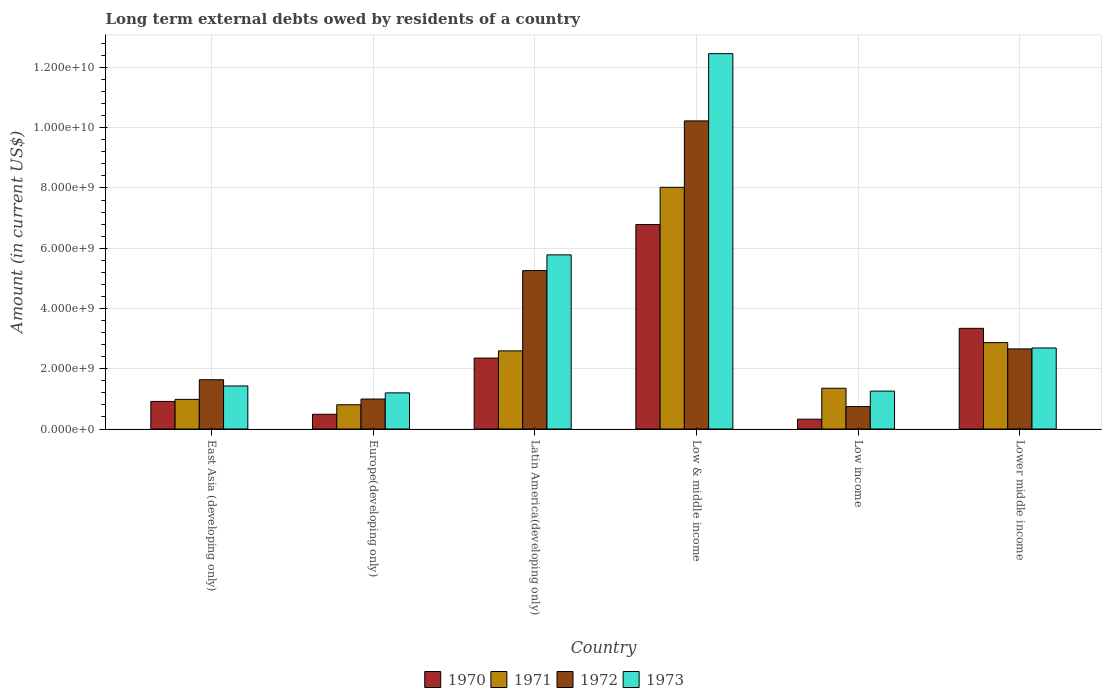Are the number of bars on each tick of the X-axis equal?
Keep it short and to the point. Yes. How many bars are there on the 6th tick from the left?
Make the answer very short. 4. What is the label of the 3rd group of bars from the left?
Offer a terse response. Latin America(developing only). In how many cases, is the number of bars for a given country not equal to the number of legend labels?
Your response must be concise. 0. What is the amount of long-term external debts owed by residents in 1973 in Latin America(developing only)?
Offer a very short reply. 5.78e+09. Across all countries, what is the maximum amount of long-term external debts owed by residents in 1970?
Make the answer very short. 6.79e+09. Across all countries, what is the minimum amount of long-term external debts owed by residents in 1973?
Your response must be concise. 1.20e+09. In which country was the amount of long-term external debts owed by residents in 1972 maximum?
Keep it short and to the point. Low & middle income. What is the total amount of long-term external debts owed by residents in 1972 in the graph?
Your answer should be compact. 2.15e+1. What is the difference between the amount of long-term external debts owed by residents in 1971 in Europe(developing only) and that in Lower middle income?
Offer a terse response. -2.06e+09. What is the difference between the amount of long-term external debts owed by residents in 1971 in Low income and the amount of long-term external debts owed by residents in 1970 in Lower middle income?
Ensure brevity in your answer.  -1.99e+09. What is the average amount of long-term external debts owed by residents in 1973 per country?
Give a very brief answer. 4.14e+09. What is the difference between the amount of long-term external debts owed by residents of/in 1971 and amount of long-term external debts owed by residents of/in 1972 in Low income?
Offer a very short reply. 6.10e+08. In how many countries, is the amount of long-term external debts owed by residents in 1973 greater than 400000000 US$?
Provide a succinct answer. 6. What is the ratio of the amount of long-term external debts owed by residents in 1971 in Europe(developing only) to that in Low & middle income?
Keep it short and to the point. 0.1. Is the amount of long-term external debts owed by residents in 1970 in Latin America(developing only) less than that in Lower middle income?
Your answer should be very brief. Yes. What is the difference between the highest and the second highest amount of long-term external debts owed by residents in 1972?
Make the answer very short. 7.57e+09. What is the difference between the highest and the lowest amount of long-term external debts owed by residents in 1971?
Provide a short and direct response. 7.22e+09. In how many countries, is the amount of long-term external debts owed by residents in 1971 greater than the average amount of long-term external debts owed by residents in 1971 taken over all countries?
Ensure brevity in your answer.  2. Is it the case that in every country, the sum of the amount of long-term external debts owed by residents in 1973 and amount of long-term external debts owed by residents in 1970 is greater than the sum of amount of long-term external debts owed by residents in 1971 and amount of long-term external debts owed by residents in 1972?
Keep it short and to the point. No. What does the 1st bar from the right in East Asia (developing only) represents?
Your response must be concise. 1973. Is it the case that in every country, the sum of the amount of long-term external debts owed by residents in 1971 and amount of long-term external debts owed by residents in 1970 is greater than the amount of long-term external debts owed by residents in 1973?
Offer a terse response. No. How many bars are there?
Keep it short and to the point. 24. What is the difference between two consecutive major ticks on the Y-axis?
Offer a terse response. 2.00e+09. Does the graph contain any zero values?
Keep it short and to the point. No. Where does the legend appear in the graph?
Your response must be concise. Bottom center. What is the title of the graph?
Give a very brief answer. Long term external debts owed by residents of a country. Does "2011" appear as one of the legend labels in the graph?
Provide a succinct answer. No. What is the label or title of the X-axis?
Keep it short and to the point. Country. What is the Amount (in current US$) in 1970 in East Asia (developing only)?
Your answer should be compact. 9.15e+08. What is the Amount (in current US$) in 1971 in East Asia (developing only)?
Your answer should be very brief. 9.84e+08. What is the Amount (in current US$) of 1972 in East Asia (developing only)?
Your response must be concise. 1.64e+09. What is the Amount (in current US$) of 1973 in East Asia (developing only)?
Provide a succinct answer. 1.43e+09. What is the Amount (in current US$) of 1970 in Europe(developing only)?
Your response must be concise. 4.89e+08. What is the Amount (in current US$) of 1971 in Europe(developing only)?
Provide a short and direct response. 8.05e+08. What is the Amount (in current US$) of 1972 in Europe(developing only)?
Provide a succinct answer. 9.95e+08. What is the Amount (in current US$) in 1973 in Europe(developing only)?
Offer a terse response. 1.20e+09. What is the Amount (in current US$) of 1970 in Latin America(developing only)?
Your response must be concise. 2.35e+09. What is the Amount (in current US$) of 1971 in Latin America(developing only)?
Make the answer very short. 2.59e+09. What is the Amount (in current US$) of 1972 in Latin America(developing only)?
Offer a very short reply. 5.26e+09. What is the Amount (in current US$) of 1973 in Latin America(developing only)?
Ensure brevity in your answer.  5.78e+09. What is the Amount (in current US$) in 1970 in Low & middle income?
Make the answer very short. 6.79e+09. What is the Amount (in current US$) of 1971 in Low & middle income?
Your answer should be compact. 8.02e+09. What is the Amount (in current US$) of 1972 in Low & middle income?
Your answer should be compact. 1.02e+1. What is the Amount (in current US$) in 1973 in Low & middle income?
Give a very brief answer. 1.25e+1. What is the Amount (in current US$) of 1970 in Low income?
Keep it short and to the point. 3.26e+08. What is the Amount (in current US$) in 1971 in Low income?
Provide a short and direct response. 1.35e+09. What is the Amount (in current US$) of 1972 in Low income?
Ensure brevity in your answer.  7.44e+08. What is the Amount (in current US$) in 1973 in Low income?
Offer a terse response. 1.26e+09. What is the Amount (in current US$) of 1970 in Lower middle income?
Offer a very short reply. 3.34e+09. What is the Amount (in current US$) in 1971 in Lower middle income?
Offer a very short reply. 2.87e+09. What is the Amount (in current US$) of 1972 in Lower middle income?
Your answer should be compact. 2.66e+09. What is the Amount (in current US$) of 1973 in Lower middle income?
Provide a short and direct response. 2.69e+09. Across all countries, what is the maximum Amount (in current US$) in 1970?
Make the answer very short. 6.79e+09. Across all countries, what is the maximum Amount (in current US$) of 1971?
Make the answer very short. 8.02e+09. Across all countries, what is the maximum Amount (in current US$) in 1972?
Provide a short and direct response. 1.02e+1. Across all countries, what is the maximum Amount (in current US$) in 1973?
Give a very brief answer. 1.25e+1. Across all countries, what is the minimum Amount (in current US$) in 1970?
Ensure brevity in your answer.  3.26e+08. Across all countries, what is the minimum Amount (in current US$) of 1971?
Your answer should be compact. 8.05e+08. Across all countries, what is the minimum Amount (in current US$) in 1972?
Give a very brief answer. 7.44e+08. Across all countries, what is the minimum Amount (in current US$) of 1973?
Offer a very short reply. 1.20e+09. What is the total Amount (in current US$) in 1970 in the graph?
Your response must be concise. 1.42e+1. What is the total Amount (in current US$) in 1971 in the graph?
Offer a terse response. 1.66e+1. What is the total Amount (in current US$) of 1972 in the graph?
Your answer should be compact. 2.15e+1. What is the total Amount (in current US$) of 1973 in the graph?
Ensure brevity in your answer.  2.48e+1. What is the difference between the Amount (in current US$) in 1970 in East Asia (developing only) and that in Europe(developing only)?
Your answer should be compact. 4.26e+08. What is the difference between the Amount (in current US$) in 1971 in East Asia (developing only) and that in Europe(developing only)?
Keep it short and to the point. 1.79e+08. What is the difference between the Amount (in current US$) in 1972 in East Asia (developing only) and that in Europe(developing only)?
Provide a succinct answer. 6.40e+08. What is the difference between the Amount (in current US$) of 1973 in East Asia (developing only) and that in Europe(developing only)?
Provide a short and direct response. 2.29e+08. What is the difference between the Amount (in current US$) in 1970 in East Asia (developing only) and that in Latin America(developing only)?
Keep it short and to the point. -1.44e+09. What is the difference between the Amount (in current US$) in 1971 in East Asia (developing only) and that in Latin America(developing only)?
Your response must be concise. -1.61e+09. What is the difference between the Amount (in current US$) in 1972 in East Asia (developing only) and that in Latin America(developing only)?
Give a very brief answer. -3.62e+09. What is the difference between the Amount (in current US$) of 1973 in East Asia (developing only) and that in Latin America(developing only)?
Keep it short and to the point. -4.35e+09. What is the difference between the Amount (in current US$) in 1970 in East Asia (developing only) and that in Low & middle income?
Offer a very short reply. -5.87e+09. What is the difference between the Amount (in current US$) in 1971 in East Asia (developing only) and that in Low & middle income?
Offer a terse response. -7.04e+09. What is the difference between the Amount (in current US$) of 1972 in East Asia (developing only) and that in Low & middle income?
Provide a short and direct response. -8.59e+09. What is the difference between the Amount (in current US$) of 1973 in East Asia (developing only) and that in Low & middle income?
Provide a short and direct response. -1.10e+1. What is the difference between the Amount (in current US$) of 1970 in East Asia (developing only) and that in Low income?
Your answer should be compact. 5.89e+08. What is the difference between the Amount (in current US$) in 1971 in East Asia (developing only) and that in Low income?
Offer a very short reply. -3.69e+08. What is the difference between the Amount (in current US$) of 1972 in East Asia (developing only) and that in Low income?
Keep it short and to the point. 8.92e+08. What is the difference between the Amount (in current US$) of 1973 in East Asia (developing only) and that in Low income?
Your response must be concise. 1.72e+08. What is the difference between the Amount (in current US$) of 1970 in East Asia (developing only) and that in Lower middle income?
Your answer should be very brief. -2.43e+09. What is the difference between the Amount (in current US$) in 1971 in East Asia (developing only) and that in Lower middle income?
Your response must be concise. -1.88e+09. What is the difference between the Amount (in current US$) of 1972 in East Asia (developing only) and that in Lower middle income?
Provide a succinct answer. -1.02e+09. What is the difference between the Amount (in current US$) in 1973 in East Asia (developing only) and that in Lower middle income?
Make the answer very short. -1.26e+09. What is the difference between the Amount (in current US$) in 1970 in Europe(developing only) and that in Latin America(developing only)?
Your answer should be compact. -1.86e+09. What is the difference between the Amount (in current US$) in 1971 in Europe(developing only) and that in Latin America(developing only)?
Keep it short and to the point. -1.79e+09. What is the difference between the Amount (in current US$) of 1972 in Europe(developing only) and that in Latin America(developing only)?
Make the answer very short. -4.26e+09. What is the difference between the Amount (in current US$) of 1973 in Europe(developing only) and that in Latin America(developing only)?
Your answer should be very brief. -4.58e+09. What is the difference between the Amount (in current US$) of 1970 in Europe(developing only) and that in Low & middle income?
Your answer should be compact. -6.30e+09. What is the difference between the Amount (in current US$) in 1971 in Europe(developing only) and that in Low & middle income?
Offer a terse response. -7.22e+09. What is the difference between the Amount (in current US$) of 1972 in Europe(developing only) and that in Low & middle income?
Ensure brevity in your answer.  -9.23e+09. What is the difference between the Amount (in current US$) in 1973 in Europe(developing only) and that in Low & middle income?
Give a very brief answer. -1.13e+1. What is the difference between the Amount (in current US$) in 1970 in Europe(developing only) and that in Low income?
Your response must be concise. 1.63e+08. What is the difference between the Amount (in current US$) in 1971 in Europe(developing only) and that in Low income?
Offer a very short reply. -5.49e+08. What is the difference between the Amount (in current US$) of 1972 in Europe(developing only) and that in Low income?
Give a very brief answer. 2.51e+08. What is the difference between the Amount (in current US$) of 1973 in Europe(developing only) and that in Low income?
Provide a short and direct response. -5.78e+07. What is the difference between the Amount (in current US$) of 1970 in Europe(developing only) and that in Lower middle income?
Give a very brief answer. -2.85e+09. What is the difference between the Amount (in current US$) in 1971 in Europe(developing only) and that in Lower middle income?
Ensure brevity in your answer.  -2.06e+09. What is the difference between the Amount (in current US$) of 1972 in Europe(developing only) and that in Lower middle income?
Provide a short and direct response. -1.66e+09. What is the difference between the Amount (in current US$) in 1973 in Europe(developing only) and that in Lower middle income?
Give a very brief answer. -1.49e+09. What is the difference between the Amount (in current US$) of 1970 in Latin America(developing only) and that in Low & middle income?
Your answer should be compact. -4.43e+09. What is the difference between the Amount (in current US$) in 1971 in Latin America(developing only) and that in Low & middle income?
Ensure brevity in your answer.  -5.43e+09. What is the difference between the Amount (in current US$) in 1972 in Latin America(developing only) and that in Low & middle income?
Ensure brevity in your answer.  -4.97e+09. What is the difference between the Amount (in current US$) in 1973 in Latin America(developing only) and that in Low & middle income?
Provide a short and direct response. -6.68e+09. What is the difference between the Amount (in current US$) in 1970 in Latin America(developing only) and that in Low income?
Ensure brevity in your answer.  2.03e+09. What is the difference between the Amount (in current US$) of 1971 in Latin America(developing only) and that in Low income?
Your response must be concise. 1.24e+09. What is the difference between the Amount (in current US$) of 1972 in Latin America(developing only) and that in Low income?
Offer a very short reply. 4.51e+09. What is the difference between the Amount (in current US$) in 1973 in Latin America(developing only) and that in Low income?
Ensure brevity in your answer.  4.52e+09. What is the difference between the Amount (in current US$) in 1970 in Latin America(developing only) and that in Lower middle income?
Keep it short and to the point. -9.88e+08. What is the difference between the Amount (in current US$) in 1971 in Latin America(developing only) and that in Lower middle income?
Offer a terse response. -2.74e+08. What is the difference between the Amount (in current US$) in 1972 in Latin America(developing only) and that in Lower middle income?
Give a very brief answer. 2.60e+09. What is the difference between the Amount (in current US$) in 1973 in Latin America(developing only) and that in Lower middle income?
Make the answer very short. 3.09e+09. What is the difference between the Amount (in current US$) of 1970 in Low & middle income and that in Low income?
Your answer should be compact. 6.46e+09. What is the difference between the Amount (in current US$) of 1971 in Low & middle income and that in Low income?
Make the answer very short. 6.67e+09. What is the difference between the Amount (in current US$) of 1972 in Low & middle income and that in Low income?
Make the answer very short. 9.48e+09. What is the difference between the Amount (in current US$) in 1973 in Low & middle income and that in Low income?
Ensure brevity in your answer.  1.12e+1. What is the difference between the Amount (in current US$) of 1970 in Low & middle income and that in Lower middle income?
Offer a terse response. 3.44e+09. What is the difference between the Amount (in current US$) of 1971 in Low & middle income and that in Lower middle income?
Give a very brief answer. 5.15e+09. What is the difference between the Amount (in current US$) in 1972 in Low & middle income and that in Lower middle income?
Provide a succinct answer. 7.57e+09. What is the difference between the Amount (in current US$) of 1973 in Low & middle income and that in Lower middle income?
Provide a short and direct response. 9.77e+09. What is the difference between the Amount (in current US$) in 1970 in Low income and that in Lower middle income?
Make the answer very short. -3.02e+09. What is the difference between the Amount (in current US$) in 1971 in Low income and that in Lower middle income?
Ensure brevity in your answer.  -1.51e+09. What is the difference between the Amount (in current US$) of 1972 in Low income and that in Lower middle income?
Provide a short and direct response. -1.91e+09. What is the difference between the Amount (in current US$) of 1973 in Low income and that in Lower middle income?
Provide a short and direct response. -1.43e+09. What is the difference between the Amount (in current US$) of 1970 in East Asia (developing only) and the Amount (in current US$) of 1971 in Europe(developing only)?
Offer a very short reply. 1.10e+08. What is the difference between the Amount (in current US$) in 1970 in East Asia (developing only) and the Amount (in current US$) in 1972 in Europe(developing only)?
Make the answer very short. -7.99e+07. What is the difference between the Amount (in current US$) in 1970 in East Asia (developing only) and the Amount (in current US$) in 1973 in Europe(developing only)?
Give a very brief answer. -2.85e+08. What is the difference between the Amount (in current US$) of 1971 in East Asia (developing only) and the Amount (in current US$) of 1972 in Europe(developing only)?
Make the answer very short. -1.11e+07. What is the difference between the Amount (in current US$) in 1971 in East Asia (developing only) and the Amount (in current US$) in 1973 in Europe(developing only)?
Offer a very short reply. -2.16e+08. What is the difference between the Amount (in current US$) in 1972 in East Asia (developing only) and the Amount (in current US$) in 1973 in Europe(developing only)?
Offer a terse response. 4.35e+08. What is the difference between the Amount (in current US$) of 1970 in East Asia (developing only) and the Amount (in current US$) of 1971 in Latin America(developing only)?
Your response must be concise. -1.68e+09. What is the difference between the Amount (in current US$) in 1970 in East Asia (developing only) and the Amount (in current US$) in 1972 in Latin America(developing only)?
Provide a succinct answer. -4.34e+09. What is the difference between the Amount (in current US$) of 1970 in East Asia (developing only) and the Amount (in current US$) of 1973 in Latin America(developing only)?
Ensure brevity in your answer.  -4.86e+09. What is the difference between the Amount (in current US$) of 1971 in East Asia (developing only) and the Amount (in current US$) of 1972 in Latin America(developing only)?
Ensure brevity in your answer.  -4.27e+09. What is the difference between the Amount (in current US$) of 1971 in East Asia (developing only) and the Amount (in current US$) of 1973 in Latin America(developing only)?
Offer a very short reply. -4.80e+09. What is the difference between the Amount (in current US$) in 1972 in East Asia (developing only) and the Amount (in current US$) in 1973 in Latin America(developing only)?
Keep it short and to the point. -4.14e+09. What is the difference between the Amount (in current US$) in 1970 in East Asia (developing only) and the Amount (in current US$) in 1971 in Low & middle income?
Your answer should be very brief. -7.11e+09. What is the difference between the Amount (in current US$) in 1970 in East Asia (developing only) and the Amount (in current US$) in 1972 in Low & middle income?
Ensure brevity in your answer.  -9.31e+09. What is the difference between the Amount (in current US$) in 1970 in East Asia (developing only) and the Amount (in current US$) in 1973 in Low & middle income?
Your answer should be very brief. -1.15e+1. What is the difference between the Amount (in current US$) of 1971 in East Asia (developing only) and the Amount (in current US$) of 1972 in Low & middle income?
Give a very brief answer. -9.24e+09. What is the difference between the Amount (in current US$) in 1971 in East Asia (developing only) and the Amount (in current US$) in 1973 in Low & middle income?
Ensure brevity in your answer.  -1.15e+1. What is the difference between the Amount (in current US$) of 1972 in East Asia (developing only) and the Amount (in current US$) of 1973 in Low & middle income?
Your answer should be compact. -1.08e+1. What is the difference between the Amount (in current US$) in 1970 in East Asia (developing only) and the Amount (in current US$) in 1971 in Low income?
Keep it short and to the point. -4.38e+08. What is the difference between the Amount (in current US$) of 1970 in East Asia (developing only) and the Amount (in current US$) of 1972 in Low income?
Offer a terse response. 1.72e+08. What is the difference between the Amount (in current US$) of 1970 in East Asia (developing only) and the Amount (in current US$) of 1973 in Low income?
Keep it short and to the point. -3.42e+08. What is the difference between the Amount (in current US$) in 1971 in East Asia (developing only) and the Amount (in current US$) in 1972 in Low income?
Offer a terse response. 2.40e+08. What is the difference between the Amount (in current US$) of 1971 in East Asia (developing only) and the Amount (in current US$) of 1973 in Low income?
Make the answer very short. -2.74e+08. What is the difference between the Amount (in current US$) of 1972 in East Asia (developing only) and the Amount (in current US$) of 1973 in Low income?
Provide a short and direct response. 3.78e+08. What is the difference between the Amount (in current US$) of 1970 in East Asia (developing only) and the Amount (in current US$) of 1971 in Lower middle income?
Your answer should be compact. -1.95e+09. What is the difference between the Amount (in current US$) in 1970 in East Asia (developing only) and the Amount (in current US$) in 1972 in Lower middle income?
Keep it short and to the point. -1.74e+09. What is the difference between the Amount (in current US$) of 1970 in East Asia (developing only) and the Amount (in current US$) of 1973 in Lower middle income?
Offer a very short reply. -1.78e+09. What is the difference between the Amount (in current US$) of 1971 in East Asia (developing only) and the Amount (in current US$) of 1972 in Lower middle income?
Offer a very short reply. -1.67e+09. What is the difference between the Amount (in current US$) of 1971 in East Asia (developing only) and the Amount (in current US$) of 1973 in Lower middle income?
Make the answer very short. -1.71e+09. What is the difference between the Amount (in current US$) of 1972 in East Asia (developing only) and the Amount (in current US$) of 1973 in Lower middle income?
Your response must be concise. -1.06e+09. What is the difference between the Amount (in current US$) in 1970 in Europe(developing only) and the Amount (in current US$) in 1971 in Latin America(developing only)?
Provide a succinct answer. -2.10e+09. What is the difference between the Amount (in current US$) of 1970 in Europe(developing only) and the Amount (in current US$) of 1972 in Latin America(developing only)?
Provide a succinct answer. -4.77e+09. What is the difference between the Amount (in current US$) in 1970 in Europe(developing only) and the Amount (in current US$) in 1973 in Latin America(developing only)?
Ensure brevity in your answer.  -5.29e+09. What is the difference between the Amount (in current US$) in 1971 in Europe(developing only) and the Amount (in current US$) in 1972 in Latin America(developing only)?
Your answer should be very brief. -4.45e+09. What is the difference between the Amount (in current US$) in 1971 in Europe(developing only) and the Amount (in current US$) in 1973 in Latin America(developing only)?
Offer a very short reply. -4.98e+09. What is the difference between the Amount (in current US$) of 1972 in Europe(developing only) and the Amount (in current US$) of 1973 in Latin America(developing only)?
Offer a terse response. -4.78e+09. What is the difference between the Amount (in current US$) of 1970 in Europe(developing only) and the Amount (in current US$) of 1971 in Low & middle income?
Provide a short and direct response. -7.53e+09. What is the difference between the Amount (in current US$) in 1970 in Europe(developing only) and the Amount (in current US$) in 1972 in Low & middle income?
Offer a terse response. -9.74e+09. What is the difference between the Amount (in current US$) of 1970 in Europe(developing only) and the Amount (in current US$) of 1973 in Low & middle income?
Your response must be concise. -1.20e+1. What is the difference between the Amount (in current US$) in 1971 in Europe(developing only) and the Amount (in current US$) in 1972 in Low & middle income?
Your response must be concise. -9.42e+09. What is the difference between the Amount (in current US$) of 1971 in Europe(developing only) and the Amount (in current US$) of 1973 in Low & middle income?
Your answer should be compact. -1.17e+1. What is the difference between the Amount (in current US$) in 1972 in Europe(developing only) and the Amount (in current US$) in 1973 in Low & middle income?
Keep it short and to the point. -1.15e+1. What is the difference between the Amount (in current US$) of 1970 in Europe(developing only) and the Amount (in current US$) of 1971 in Low income?
Ensure brevity in your answer.  -8.64e+08. What is the difference between the Amount (in current US$) in 1970 in Europe(developing only) and the Amount (in current US$) in 1972 in Low income?
Offer a terse response. -2.55e+08. What is the difference between the Amount (in current US$) of 1970 in Europe(developing only) and the Amount (in current US$) of 1973 in Low income?
Offer a very short reply. -7.69e+08. What is the difference between the Amount (in current US$) in 1971 in Europe(developing only) and the Amount (in current US$) in 1972 in Low income?
Offer a terse response. 6.12e+07. What is the difference between the Amount (in current US$) in 1971 in Europe(developing only) and the Amount (in current US$) in 1973 in Low income?
Your answer should be very brief. -4.53e+08. What is the difference between the Amount (in current US$) of 1972 in Europe(developing only) and the Amount (in current US$) of 1973 in Low income?
Provide a succinct answer. -2.63e+08. What is the difference between the Amount (in current US$) of 1970 in Europe(developing only) and the Amount (in current US$) of 1971 in Lower middle income?
Give a very brief answer. -2.38e+09. What is the difference between the Amount (in current US$) in 1970 in Europe(developing only) and the Amount (in current US$) in 1972 in Lower middle income?
Your response must be concise. -2.17e+09. What is the difference between the Amount (in current US$) in 1970 in Europe(developing only) and the Amount (in current US$) in 1973 in Lower middle income?
Provide a short and direct response. -2.20e+09. What is the difference between the Amount (in current US$) in 1971 in Europe(developing only) and the Amount (in current US$) in 1972 in Lower middle income?
Offer a terse response. -1.85e+09. What is the difference between the Amount (in current US$) of 1971 in Europe(developing only) and the Amount (in current US$) of 1973 in Lower middle income?
Make the answer very short. -1.89e+09. What is the difference between the Amount (in current US$) in 1972 in Europe(developing only) and the Amount (in current US$) in 1973 in Lower middle income?
Ensure brevity in your answer.  -1.70e+09. What is the difference between the Amount (in current US$) in 1970 in Latin America(developing only) and the Amount (in current US$) in 1971 in Low & middle income?
Keep it short and to the point. -5.67e+09. What is the difference between the Amount (in current US$) in 1970 in Latin America(developing only) and the Amount (in current US$) in 1972 in Low & middle income?
Provide a succinct answer. -7.87e+09. What is the difference between the Amount (in current US$) of 1970 in Latin America(developing only) and the Amount (in current US$) of 1973 in Low & middle income?
Your response must be concise. -1.01e+1. What is the difference between the Amount (in current US$) of 1971 in Latin America(developing only) and the Amount (in current US$) of 1972 in Low & middle income?
Keep it short and to the point. -7.63e+09. What is the difference between the Amount (in current US$) of 1971 in Latin America(developing only) and the Amount (in current US$) of 1973 in Low & middle income?
Make the answer very short. -9.87e+09. What is the difference between the Amount (in current US$) of 1972 in Latin America(developing only) and the Amount (in current US$) of 1973 in Low & middle income?
Offer a terse response. -7.20e+09. What is the difference between the Amount (in current US$) of 1970 in Latin America(developing only) and the Amount (in current US$) of 1971 in Low income?
Offer a terse response. 1.00e+09. What is the difference between the Amount (in current US$) in 1970 in Latin America(developing only) and the Amount (in current US$) in 1972 in Low income?
Ensure brevity in your answer.  1.61e+09. What is the difference between the Amount (in current US$) of 1970 in Latin America(developing only) and the Amount (in current US$) of 1973 in Low income?
Make the answer very short. 1.10e+09. What is the difference between the Amount (in current US$) in 1971 in Latin America(developing only) and the Amount (in current US$) in 1972 in Low income?
Offer a terse response. 1.85e+09. What is the difference between the Amount (in current US$) in 1971 in Latin America(developing only) and the Amount (in current US$) in 1973 in Low income?
Offer a terse response. 1.34e+09. What is the difference between the Amount (in current US$) in 1972 in Latin America(developing only) and the Amount (in current US$) in 1973 in Low income?
Ensure brevity in your answer.  4.00e+09. What is the difference between the Amount (in current US$) in 1970 in Latin America(developing only) and the Amount (in current US$) in 1971 in Lower middle income?
Offer a very short reply. -5.14e+08. What is the difference between the Amount (in current US$) of 1970 in Latin America(developing only) and the Amount (in current US$) of 1972 in Lower middle income?
Give a very brief answer. -3.05e+08. What is the difference between the Amount (in current US$) of 1970 in Latin America(developing only) and the Amount (in current US$) of 1973 in Lower middle income?
Provide a short and direct response. -3.37e+08. What is the difference between the Amount (in current US$) of 1971 in Latin America(developing only) and the Amount (in current US$) of 1972 in Lower middle income?
Give a very brief answer. -6.50e+07. What is the difference between the Amount (in current US$) of 1971 in Latin America(developing only) and the Amount (in current US$) of 1973 in Lower middle income?
Your answer should be very brief. -9.69e+07. What is the difference between the Amount (in current US$) in 1972 in Latin America(developing only) and the Amount (in current US$) in 1973 in Lower middle income?
Your answer should be very brief. 2.57e+09. What is the difference between the Amount (in current US$) of 1970 in Low & middle income and the Amount (in current US$) of 1971 in Low income?
Your answer should be compact. 5.43e+09. What is the difference between the Amount (in current US$) of 1970 in Low & middle income and the Amount (in current US$) of 1972 in Low income?
Provide a short and direct response. 6.04e+09. What is the difference between the Amount (in current US$) in 1970 in Low & middle income and the Amount (in current US$) in 1973 in Low income?
Ensure brevity in your answer.  5.53e+09. What is the difference between the Amount (in current US$) in 1971 in Low & middle income and the Amount (in current US$) in 1972 in Low income?
Give a very brief answer. 7.28e+09. What is the difference between the Amount (in current US$) in 1971 in Low & middle income and the Amount (in current US$) in 1973 in Low income?
Give a very brief answer. 6.76e+09. What is the difference between the Amount (in current US$) in 1972 in Low & middle income and the Amount (in current US$) in 1973 in Low income?
Make the answer very short. 8.97e+09. What is the difference between the Amount (in current US$) in 1970 in Low & middle income and the Amount (in current US$) in 1971 in Lower middle income?
Keep it short and to the point. 3.92e+09. What is the difference between the Amount (in current US$) of 1970 in Low & middle income and the Amount (in current US$) of 1972 in Lower middle income?
Your answer should be compact. 4.13e+09. What is the difference between the Amount (in current US$) in 1970 in Low & middle income and the Amount (in current US$) in 1973 in Lower middle income?
Your answer should be compact. 4.10e+09. What is the difference between the Amount (in current US$) of 1971 in Low & middle income and the Amount (in current US$) of 1972 in Lower middle income?
Provide a short and direct response. 5.36e+09. What is the difference between the Amount (in current US$) in 1971 in Low & middle income and the Amount (in current US$) in 1973 in Lower middle income?
Keep it short and to the point. 5.33e+09. What is the difference between the Amount (in current US$) of 1972 in Low & middle income and the Amount (in current US$) of 1973 in Lower middle income?
Give a very brief answer. 7.54e+09. What is the difference between the Amount (in current US$) in 1970 in Low income and the Amount (in current US$) in 1971 in Lower middle income?
Your response must be concise. -2.54e+09. What is the difference between the Amount (in current US$) of 1970 in Low income and the Amount (in current US$) of 1972 in Lower middle income?
Your answer should be very brief. -2.33e+09. What is the difference between the Amount (in current US$) of 1970 in Low income and the Amount (in current US$) of 1973 in Lower middle income?
Provide a succinct answer. -2.36e+09. What is the difference between the Amount (in current US$) in 1971 in Low income and the Amount (in current US$) in 1972 in Lower middle income?
Offer a terse response. -1.31e+09. What is the difference between the Amount (in current US$) in 1971 in Low income and the Amount (in current US$) in 1973 in Lower middle income?
Provide a short and direct response. -1.34e+09. What is the difference between the Amount (in current US$) in 1972 in Low income and the Amount (in current US$) in 1973 in Lower middle income?
Keep it short and to the point. -1.95e+09. What is the average Amount (in current US$) of 1970 per country?
Keep it short and to the point. 2.37e+09. What is the average Amount (in current US$) of 1971 per country?
Offer a very short reply. 2.77e+09. What is the average Amount (in current US$) in 1972 per country?
Make the answer very short. 3.59e+09. What is the average Amount (in current US$) in 1973 per country?
Your response must be concise. 4.14e+09. What is the difference between the Amount (in current US$) in 1970 and Amount (in current US$) in 1971 in East Asia (developing only)?
Your answer should be compact. -6.88e+07. What is the difference between the Amount (in current US$) in 1970 and Amount (in current US$) in 1972 in East Asia (developing only)?
Offer a very short reply. -7.20e+08. What is the difference between the Amount (in current US$) of 1970 and Amount (in current US$) of 1973 in East Asia (developing only)?
Your answer should be very brief. -5.14e+08. What is the difference between the Amount (in current US$) of 1971 and Amount (in current US$) of 1972 in East Asia (developing only)?
Offer a terse response. -6.51e+08. What is the difference between the Amount (in current US$) of 1971 and Amount (in current US$) of 1973 in East Asia (developing only)?
Make the answer very short. -4.45e+08. What is the difference between the Amount (in current US$) of 1972 and Amount (in current US$) of 1973 in East Asia (developing only)?
Provide a succinct answer. 2.06e+08. What is the difference between the Amount (in current US$) in 1970 and Amount (in current US$) in 1971 in Europe(developing only)?
Make the answer very short. -3.16e+08. What is the difference between the Amount (in current US$) in 1970 and Amount (in current US$) in 1972 in Europe(developing only)?
Your response must be concise. -5.06e+08. What is the difference between the Amount (in current US$) in 1970 and Amount (in current US$) in 1973 in Europe(developing only)?
Keep it short and to the point. -7.11e+08. What is the difference between the Amount (in current US$) in 1971 and Amount (in current US$) in 1972 in Europe(developing only)?
Provide a short and direct response. -1.90e+08. What is the difference between the Amount (in current US$) in 1971 and Amount (in current US$) in 1973 in Europe(developing only)?
Keep it short and to the point. -3.95e+08. What is the difference between the Amount (in current US$) of 1972 and Amount (in current US$) of 1973 in Europe(developing only)?
Provide a short and direct response. -2.05e+08. What is the difference between the Amount (in current US$) of 1970 and Amount (in current US$) of 1971 in Latin America(developing only)?
Ensure brevity in your answer.  -2.40e+08. What is the difference between the Amount (in current US$) in 1970 and Amount (in current US$) in 1972 in Latin America(developing only)?
Ensure brevity in your answer.  -2.90e+09. What is the difference between the Amount (in current US$) in 1970 and Amount (in current US$) in 1973 in Latin America(developing only)?
Give a very brief answer. -3.43e+09. What is the difference between the Amount (in current US$) in 1971 and Amount (in current US$) in 1972 in Latin America(developing only)?
Make the answer very short. -2.66e+09. What is the difference between the Amount (in current US$) of 1971 and Amount (in current US$) of 1973 in Latin America(developing only)?
Offer a very short reply. -3.19e+09. What is the difference between the Amount (in current US$) in 1972 and Amount (in current US$) in 1973 in Latin America(developing only)?
Offer a very short reply. -5.22e+08. What is the difference between the Amount (in current US$) in 1970 and Amount (in current US$) in 1971 in Low & middle income?
Make the answer very short. -1.24e+09. What is the difference between the Amount (in current US$) in 1970 and Amount (in current US$) in 1972 in Low & middle income?
Make the answer very short. -3.44e+09. What is the difference between the Amount (in current US$) of 1970 and Amount (in current US$) of 1973 in Low & middle income?
Offer a terse response. -5.67e+09. What is the difference between the Amount (in current US$) of 1971 and Amount (in current US$) of 1972 in Low & middle income?
Offer a terse response. -2.20e+09. What is the difference between the Amount (in current US$) of 1971 and Amount (in current US$) of 1973 in Low & middle income?
Keep it short and to the point. -4.44e+09. What is the difference between the Amount (in current US$) in 1972 and Amount (in current US$) in 1973 in Low & middle income?
Your answer should be very brief. -2.23e+09. What is the difference between the Amount (in current US$) of 1970 and Amount (in current US$) of 1971 in Low income?
Offer a terse response. -1.03e+09. What is the difference between the Amount (in current US$) in 1970 and Amount (in current US$) in 1972 in Low income?
Your answer should be very brief. -4.17e+08. What is the difference between the Amount (in current US$) of 1970 and Amount (in current US$) of 1973 in Low income?
Offer a very short reply. -9.31e+08. What is the difference between the Amount (in current US$) of 1971 and Amount (in current US$) of 1972 in Low income?
Provide a short and direct response. 6.10e+08. What is the difference between the Amount (in current US$) of 1971 and Amount (in current US$) of 1973 in Low income?
Offer a very short reply. 9.57e+07. What is the difference between the Amount (in current US$) of 1972 and Amount (in current US$) of 1973 in Low income?
Your response must be concise. -5.14e+08. What is the difference between the Amount (in current US$) in 1970 and Amount (in current US$) in 1971 in Lower middle income?
Your response must be concise. 4.74e+08. What is the difference between the Amount (in current US$) in 1970 and Amount (in current US$) in 1972 in Lower middle income?
Keep it short and to the point. 6.83e+08. What is the difference between the Amount (in current US$) in 1970 and Amount (in current US$) in 1973 in Lower middle income?
Make the answer very short. 6.52e+08. What is the difference between the Amount (in current US$) in 1971 and Amount (in current US$) in 1972 in Lower middle income?
Give a very brief answer. 2.09e+08. What is the difference between the Amount (in current US$) in 1971 and Amount (in current US$) in 1973 in Lower middle income?
Keep it short and to the point. 1.77e+08. What is the difference between the Amount (in current US$) of 1972 and Amount (in current US$) of 1973 in Lower middle income?
Provide a succinct answer. -3.18e+07. What is the ratio of the Amount (in current US$) in 1970 in East Asia (developing only) to that in Europe(developing only)?
Your response must be concise. 1.87. What is the ratio of the Amount (in current US$) in 1971 in East Asia (developing only) to that in Europe(developing only)?
Offer a terse response. 1.22. What is the ratio of the Amount (in current US$) in 1972 in East Asia (developing only) to that in Europe(developing only)?
Provide a succinct answer. 1.64. What is the ratio of the Amount (in current US$) in 1973 in East Asia (developing only) to that in Europe(developing only)?
Make the answer very short. 1.19. What is the ratio of the Amount (in current US$) of 1970 in East Asia (developing only) to that in Latin America(developing only)?
Provide a short and direct response. 0.39. What is the ratio of the Amount (in current US$) of 1971 in East Asia (developing only) to that in Latin America(developing only)?
Your answer should be compact. 0.38. What is the ratio of the Amount (in current US$) in 1972 in East Asia (developing only) to that in Latin America(developing only)?
Offer a terse response. 0.31. What is the ratio of the Amount (in current US$) in 1973 in East Asia (developing only) to that in Latin America(developing only)?
Offer a terse response. 0.25. What is the ratio of the Amount (in current US$) in 1970 in East Asia (developing only) to that in Low & middle income?
Give a very brief answer. 0.13. What is the ratio of the Amount (in current US$) of 1971 in East Asia (developing only) to that in Low & middle income?
Keep it short and to the point. 0.12. What is the ratio of the Amount (in current US$) of 1972 in East Asia (developing only) to that in Low & middle income?
Your answer should be compact. 0.16. What is the ratio of the Amount (in current US$) in 1973 in East Asia (developing only) to that in Low & middle income?
Your answer should be very brief. 0.11. What is the ratio of the Amount (in current US$) in 1970 in East Asia (developing only) to that in Low income?
Your answer should be compact. 2.81. What is the ratio of the Amount (in current US$) of 1971 in East Asia (developing only) to that in Low income?
Provide a succinct answer. 0.73. What is the ratio of the Amount (in current US$) of 1972 in East Asia (developing only) to that in Low income?
Ensure brevity in your answer.  2.2. What is the ratio of the Amount (in current US$) in 1973 in East Asia (developing only) to that in Low income?
Make the answer very short. 1.14. What is the ratio of the Amount (in current US$) in 1970 in East Asia (developing only) to that in Lower middle income?
Ensure brevity in your answer.  0.27. What is the ratio of the Amount (in current US$) of 1971 in East Asia (developing only) to that in Lower middle income?
Your answer should be compact. 0.34. What is the ratio of the Amount (in current US$) in 1972 in East Asia (developing only) to that in Lower middle income?
Offer a terse response. 0.62. What is the ratio of the Amount (in current US$) of 1973 in East Asia (developing only) to that in Lower middle income?
Make the answer very short. 0.53. What is the ratio of the Amount (in current US$) of 1970 in Europe(developing only) to that in Latin America(developing only)?
Your answer should be compact. 0.21. What is the ratio of the Amount (in current US$) in 1971 in Europe(developing only) to that in Latin America(developing only)?
Offer a very short reply. 0.31. What is the ratio of the Amount (in current US$) of 1972 in Europe(developing only) to that in Latin America(developing only)?
Give a very brief answer. 0.19. What is the ratio of the Amount (in current US$) in 1973 in Europe(developing only) to that in Latin America(developing only)?
Your answer should be very brief. 0.21. What is the ratio of the Amount (in current US$) of 1970 in Europe(developing only) to that in Low & middle income?
Your response must be concise. 0.07. What is the ratio of the Amount (in current US$) in 1971 in Europe(developing only) to that in Low & middle income?
Provide a succinct answer. 0.1. What is the ratio of the Amount (in current US$) in 1972 in Europe(developing only) to that in Low & middle income?
Your answer should be compact. 0.1. What is the ratio of the Amount (in current US$) of 1973 in Europe(developing only) to that in Low & middle income?
Provide a short and direct response. 0.1. What is the ratio of the Amount (in current US$) in 1970 in Europe(developing only) to that in Low income?
Your answer should be compact. 1.5. What is the ratio of the Amount (in current US$) in 1971 in Europe(developing only) to that in Low income?
Your answer should be compact. 0.59. What is the ratio of the Amount (in current US$) of 1972 in Europe(developing only) to that in Low income?
Make the answer very short. 1.34. What is the ratio of the Amount (in current US$) in 1973 in Europe(developing only) to that in Low income?
Your answer should be compact. 0.95. What is the ratio of the Amount (in current US$) in 1970 in Europe(developing only) to that in Lower middle income?
Make the answer very short. 0.15. What is the ratio of the Amount (in current US$) in 1971 in Europe(developing only) to that in Lower middle income?
Provide a short and direct response. 0.28. What is the ratio of the Amount (in current US$) in 1972 in Europe(developing only) to that in Lower middle income?
Give a very brief answer. 0.37. What is the ratio of the Amount (in current US$) in 1973 in Europe(developing only) to that in Lower middle income?
Make the answer very short. 0.45. What is the ratio of the Amount (in current US$) of 1970 in Latin America(developing only) to that in Low & middle income?
Offer a terse response. 0.35. What is the ratio of the Amount (in current US$) in 1971 in Latin America(developing only) to that in Low & middle income?
Your answer should be compact. 0.32. What is the ratio of the Amount (in current US$) in 1972 in Latin America(developing only) to that in Low & middle income?
Your answer should be very brief. 0.51. What is the ratio of the Amount (in current US$) of 1973 in Latin America(developing only) to that in Low & middle income?
Offer a very short reply. 0.46. What is the ratio of the Amount (in current US$) of 1970 in Latin America(developing only) to that in Low income?
Offer a very short reply. 7.21. What is the ratio of the Amount (in current US$) of 1971 in Latin America(developing only) to that in Low income?
Your answer should be compact. 1.92. What is the ratio of the Amount (in current US$) in 1972 in Latin America(developing only) to that in Low income?
Make the answer very short. 7.07. What is the ratio of the Amount (in current US$) of 1973 in Latin America(developing only) to that in Low income?
Your response must be concise. 4.6. What is the ratio of the Amount (in current US$) in 1970 in Latin America(developing only) to that in Lower middle income?
Provide a short and direct response. 0.7. What is the ratio of the Amount (in current US$) of 1971 in Latin America(developing only) to that in Lower middle income?
Your answer should be compact. 0.9. What is the ratio of the Amount (in current US$) of 1972 in Latin America(developing only) to that in Lower middle income?
Your response must be concise. 1.98. What is the ratio of the Amount (in current US$) in 1973 in Latin America(developing only) to that in Lower middle income?
Your answer should be very brief. 2.15. What is the ratio of the Amount (in current US$) in 1970 in Low & middle income to that in Low income?
Your answer should be very brief. 20.8. What is the ratio of the Amount (in current US$) in 1971 in Low & middle income to that in Low income?
Provide a succinct answer. 5.93. What is the ratio of the Amount (in current US$) in 1972 in Low & middle income to that in Low income?
Ensure brevity in your answer.  13.75. What is the ratio of the Amount (in current US$) of 1973 in Low & middle income to that in Low income?
Your response must be concise. 9.91. What is the ratio of the Amount (in current US$) of 1970 in Low & middle income to that in Lower middle income?
Make the answer very short. 2.03. What is the ratio of the Amount (in current US$) of 1971 in Low & middle income to that in Lower middle income?
Offer a very short reply. 2.8. What is the ratio of the Amount (in current US$) in 1972 in Low & middle income to that in Lower middle income?
Offer a terse response. 3.85. What is the ratio of the Amount (in current US$) of 1973 in Low & middle income to that in Lower middle income?
Your answer should be compact. 4.63. What is the ratio of the Amount (in current US$) of 1970 in Low income to that in Lower middle income?
Your response must be concise. 0.1. What is the ratio of the Amount (in current US$) of 1971 in Low income to that in Lower middle income?
Offer a terse response. 0.47. What is the ratio of the Amount (in current US$) of 1972 in Low income to that in Lower middle income?
Your answer should be compact. 0.28. What is the ratio of the Amount (in current US$) of 1973 in Low income to that in Lower middle income?
Your answer should be very brief. 0.47. What is the difference between the highest and the second highest Amount (in current US$) of 1970?
Provide a succinct answer. 3.44e+09. What is the difference between the highest and the second highest Amount (in current US$) in 1971?
Keep it short and to the point. 5.15e+09. What is the difference between the highest and the second highest Amount (in current US$) of 1972?
Ensure brevity in your answer.  4.97e+09. What is the difference between the highest and the second highest Amount (in current US$) of 1973?
Your answer should be compact. 6.68e+09. What is the difference between the highest and the lowest Amount (in current US$) of 1970?
Provide a succinct answer. 6.46e+09. What is the difference between the highest and the lowest Amount (in current US$) in 1971?
Ensure brevity in your answer.  7.22e+09. What is the difference between the highest and the lowest Amount (in current US$) of 1972?
Provide a short and direct response. 9.48e+09. What is the difference between the highest and the lowest Amount (in current US$) in 1973?
Ensure brevity in your answer.  1.13e+1. 